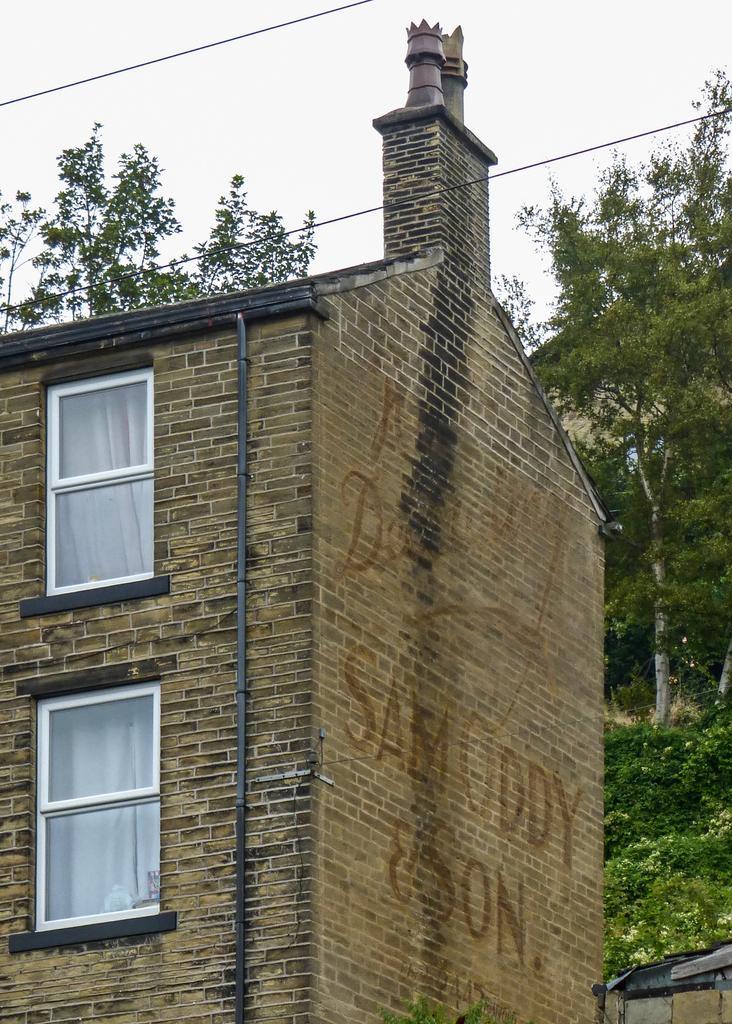Could you give a brief overview of what you see in this image? In this picture we can see few trees, cables and a building, and also we can see a pipe on the building, in the building we can see few curtains. 